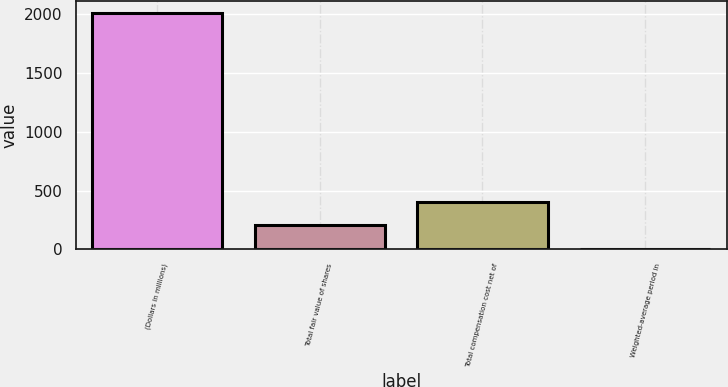Convert chart to OTSL. <chart><loc_0><loc_0><loc_500><loc_500><bar_chart><fcel>(Dollars in millions)<fcel>Total fair value of shares<fcel>Total compensation cost net of<fcel>Weighted-average period in<nl><fcel>2011<fcel>202.9<fcel>403.8<fcel>2<nl></chart> 